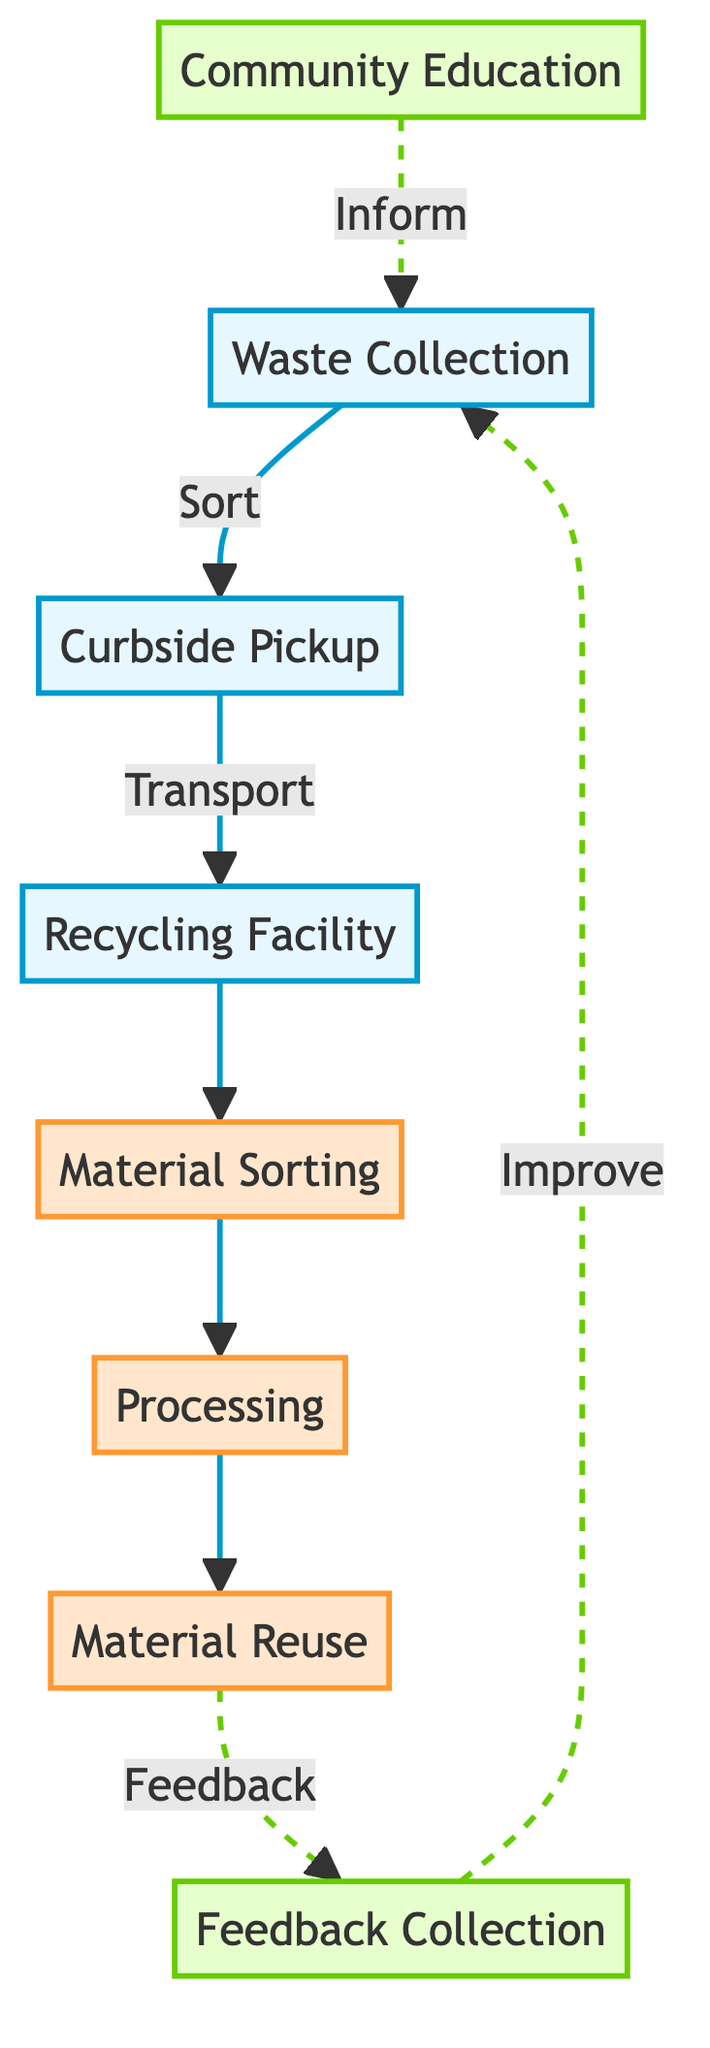What is the first step in the recycling workflow? The diagram shows that the first step is "Waste Collection," where residents sort their waste.
Answer: Waste Collection How many processing steps are there? The diagram identifies three processing steps: Material Sorting, Processing, and Material Reuse.
Answer: 3 Which node is responsible for educational outreach? The node labeled "Community Education" represents the educational outreach initiative by the GreenLeaf Initiative.
Answer: Community Education What is the relationship between Material Reuse and Feedback Collection? The diagram indicates that Material Reuse is connected to Feedback Collection through a feedback loop, implying the need for program improvement.
Answer: Feedback What follows after Transportation to Recycling Facility? According to the flow chart, the step that follows Transportation to the Recycling Facility is Material Sorting.
Answer: Material Sorting Which step connects back to Waste Collection with information? The Community Education step connects back to Waste Collection, providing information about recycling benefits and sorting techniques.
Answer: Community Education What kind of line connects Community Education to Waste Collection? A dashed line connects Community Education to Waste Collection, indicating a non-linear relationship for feedback and education.
Answer: Dashed line How many total nodes are in the diagram? By counting, there are a total of eight nodes present in the recycling workflow diagram.
Answer: 8 What do processed raw materials lead to? The processed raw materials lead to Material Reuse, where they are sold to manufacturers for new products.
Answer: Material Reuse 